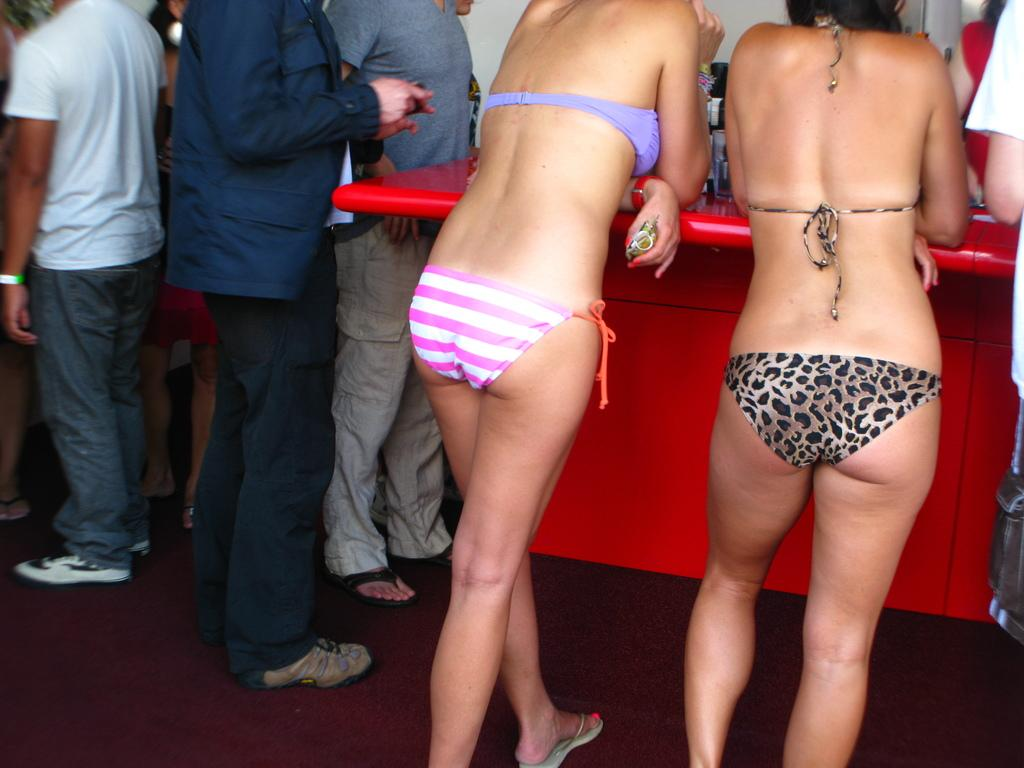What is present in the image? There are people standing in the image. Can you describe any objects or structures in the image? There is a table in the image. What can be seen in the background of the image? There is a wall in the background of the image. Is there a beggar asking for money in the image? There is no beggar present in the image. Can you see a stream of water flowing in the image? There is no stream of water present in the image. 